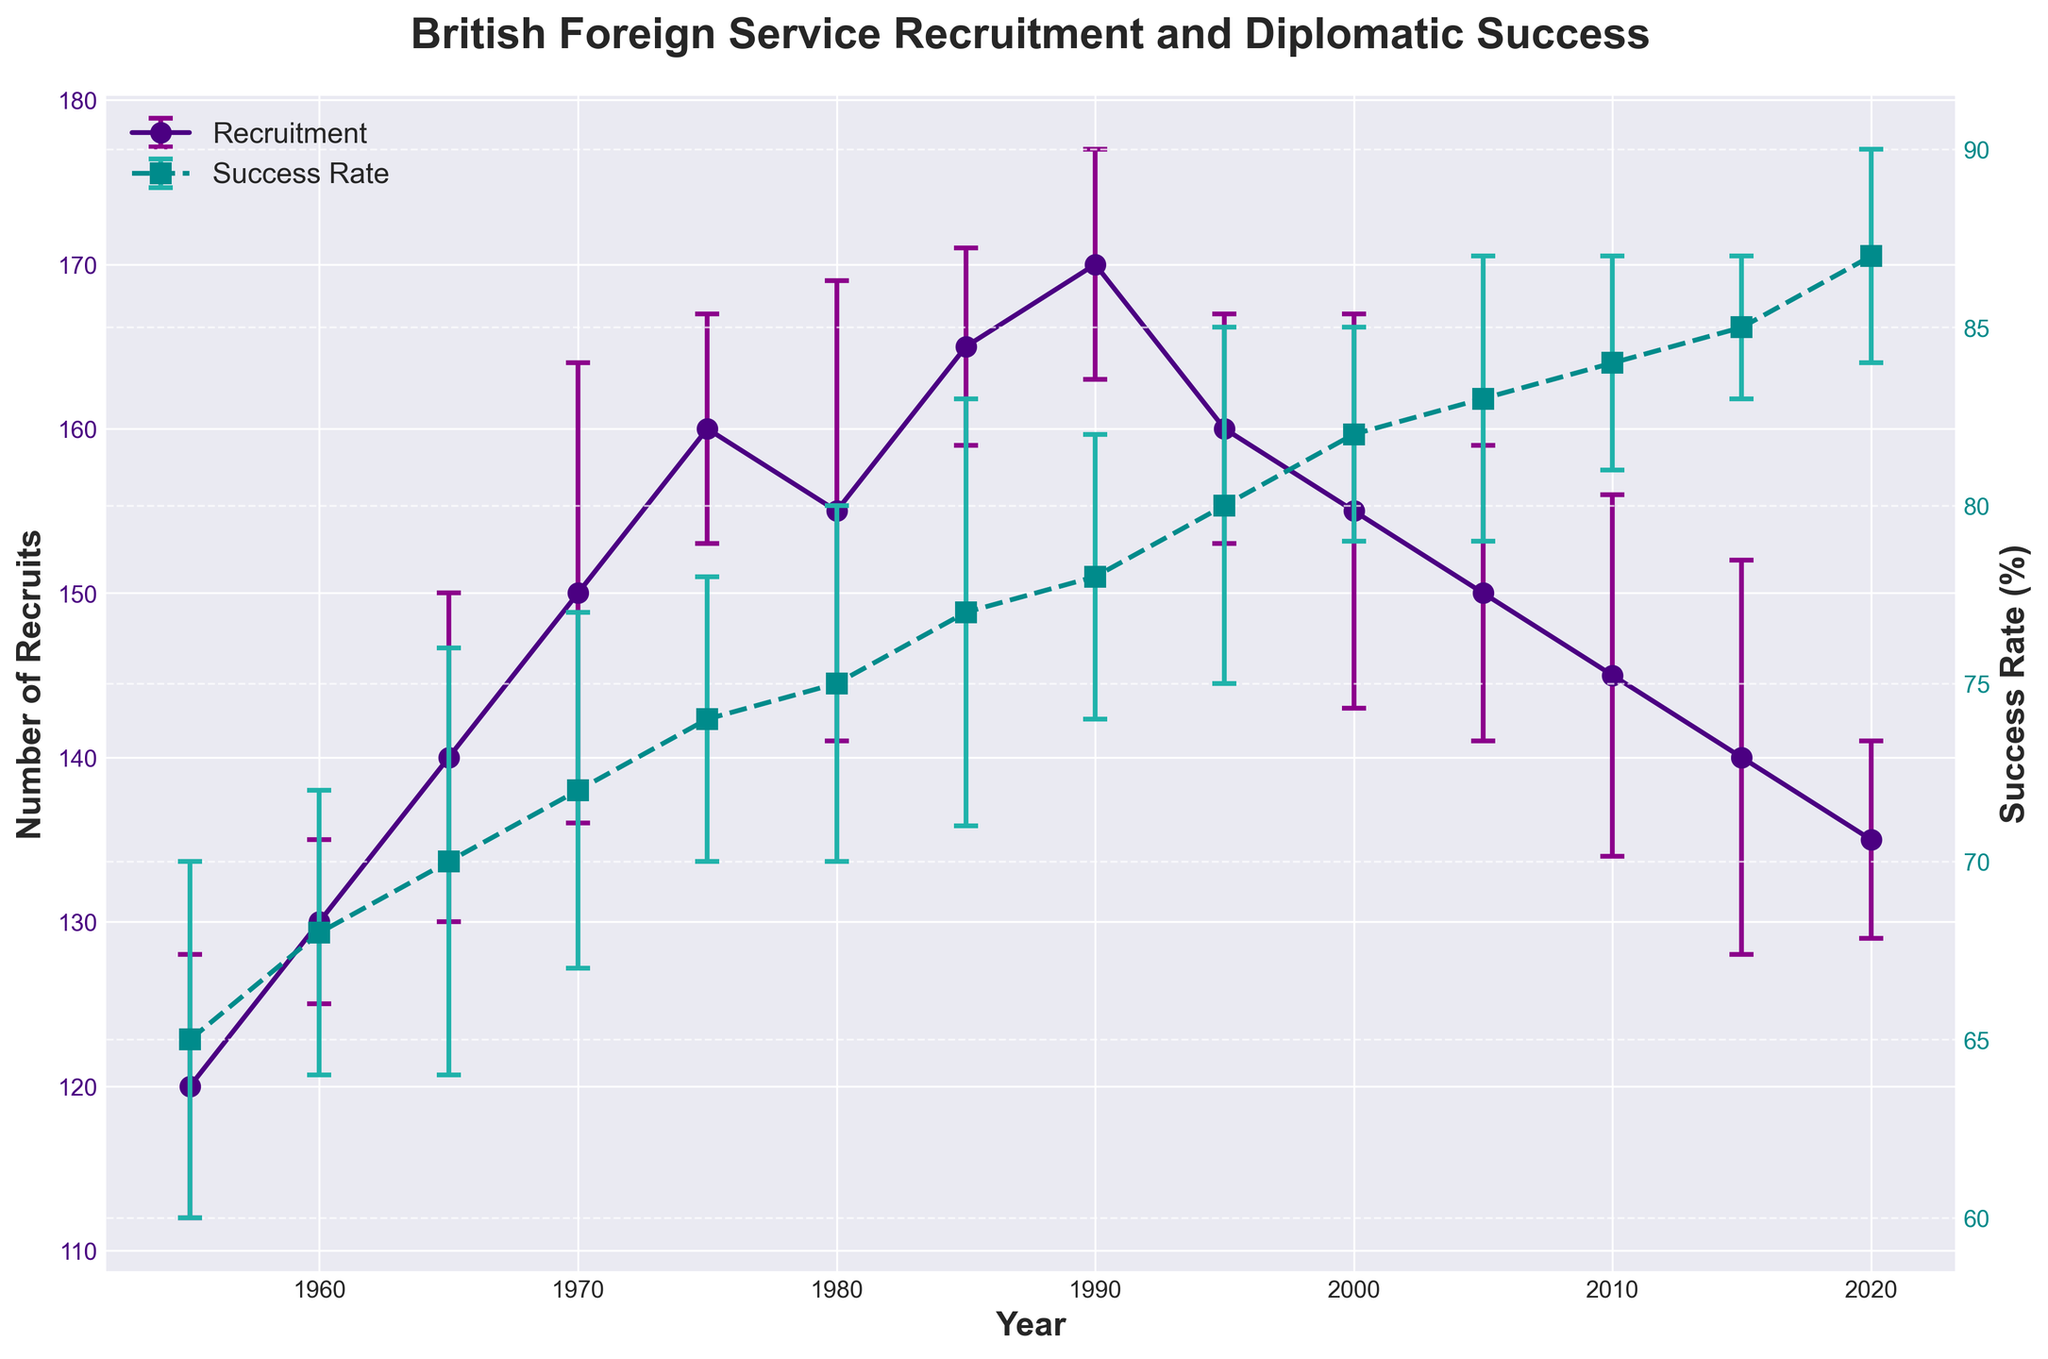What's the title of the figure? The title of the figure is written at the top of the plot, which is "British Foreign Service Recruitment and Diplomatic Success".
Answer: British Foreign Service Recruitment and Diplomatic Success What are the y-axis labels in the figure? The figure has two y-axes. The left y-axis is labeled "Number of Recruits" and the right y-axis is labeled "Success Rate (%)".
Answer: Number of Recruits, Success Rate (%) In which year did the recruitment reach its peak, and what was the value? By looking at the line for recruitment, the highest point is in the year 1990 with a value of 170 recruits.
Answer: 1990, 170 recruits How does the success rate change from 1955 to 2020? From the plotted points, the success rate gradually increases from 65% in 1955 to 87% in 2020.
Answer: Increases What is the difference in success rate between 1965 and 2000? The success rate in 1965 is 70%, and in 2000 it is 82%, so the difference is 82% - 70% = 12%.
Answer: 12% Between which consecutive years did recruitment see the largest drop, and what was the value of that drop? Recruitment decreases the most between 1990 (170 recruits) and 1995 (160 recruits), a drop of 170 - 160 = 10 recruits.
Answer: 1990-1995, 10 recruits How much did the success rate increase between 1980 and 1985? In 1980, the success rate was 75%, and in 1985 it increased to 77%, so the increase is 77% - 75% = 2%.
Answer: 2% In which year was the recruitment number closest to 150? The recruitment number is closest to 150 in the year 2005.
Answer: 2005 Which year has the smallest error bar for the success rate? The smallest error bar for the success rate is in the year 2015, which has an error of 2%.
Answer: 2015 If the success rate continued to improve beyond 2020 at the same rate as from 2015 to 2020, what would the success rate be in 2025? The success rate increased from 85% in 2015 to 87% in 2020, an increase of 2% over 5 years. Continuing this rate of increase, the success rate would be 87% + 2% = 89% in 2025.
Answer: 89% 